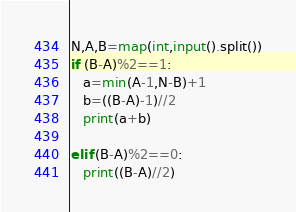Convert code to text. <code><loc_0><loc_0><loc_500><loc_500><_Python_>N,A,B=map(int,input().split())
if (B-A)%2==1:
   a=min(A-1,N-B)+1
   b=((B-A)-1)//2
   print(a+b)

elif (B-A)%2==0:
   print((B-A)//2)</code> 